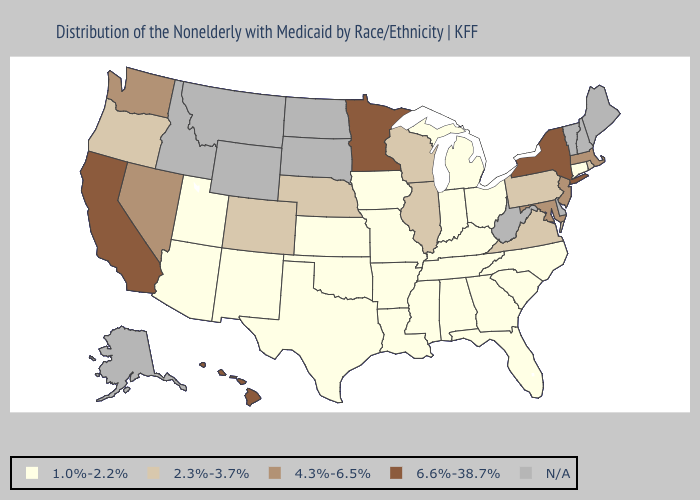Among the states that border Minnesota , which have the lowest value?
Write a very short answer. Iowa. Which states have the highest value in the USA?
Quick response, please. California, Hawaii, Minnesota, New York. Which states have the highest value in the USA?
Be succinct. California, Hawaii, Minnesota, New York. How many symbols are there in the legend?
Quick response, please. 5. What is the value of North Carolina?
Answer briefly. 1.0%-2.2%. What is the value of Montana?
Short answer required. N/A. Is the legend a continuous bar?
Give a very brief answer. No. What is the value of Arkansas?
Concise answer only. 1.0%-2.2%. Among the states that border Wisconsin , does Michigan have the lowest value?
Short answer required. Yes. Does Alabama have the highest value in the USA?
Quick response, please. No. Name the states that have a value in the range N/A?
Give a very brief answer. Alaska, Delaware, Idaho, Maine, Montana, New Hampshire, North Dakota, South Dakota, Vermont, West Virginia, Wyoming. What is the highest value in the USA?
Concise answer only. 6.6%-38.7%. Among the states that border Arkansas , which have the lowest value?
Concise answer only. Louisiana, Mississippi, Missouri, Oklahoma, Tennessee, Texas. 